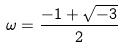Convert formula to latex. <formula><loc_0><loc_0><loc_500><loc_500>\omega = \frac { - 1 + \sqrt { - 3 } } { 2 }</formula> 